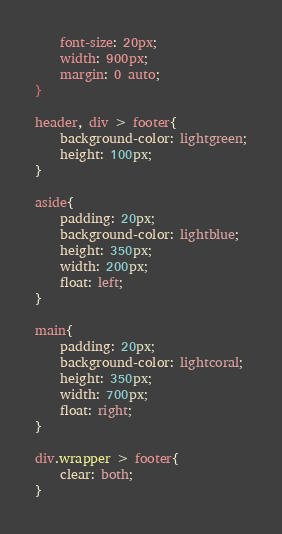<code> <loc_0><loc_0><loc_500><loc_500><_CSS_>    font-size: 20px;
    width: 900px;
    margin: 0 auto;
}

header, div > footer{
    background-color: lightgreen;
    height: 100px;
}

aside{
    padding: 20px;
    background-color: lightblue;
    height: 350px;
    width: 200px;
    float: left;
}

main{
    padding: 20px;
    background-color: lightcoral;
    height: 350px;
    width: 700px;
    float: right;
}

div.wrapper > footer{
    clear: both;
}

</code> 